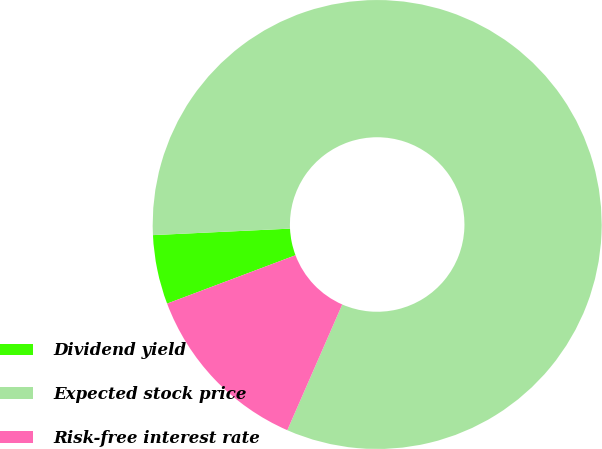Convert chart to OTSL. <chart><loc_0><loc_0><loc_500><loc_500><pie_chart><fcel>Dividend yield<fcel>Expected stock price<fcel>Risk-free interest rate<nl><fcel>4.98%<fcel>82.31%<fcel>12.71%<nl></chart> 